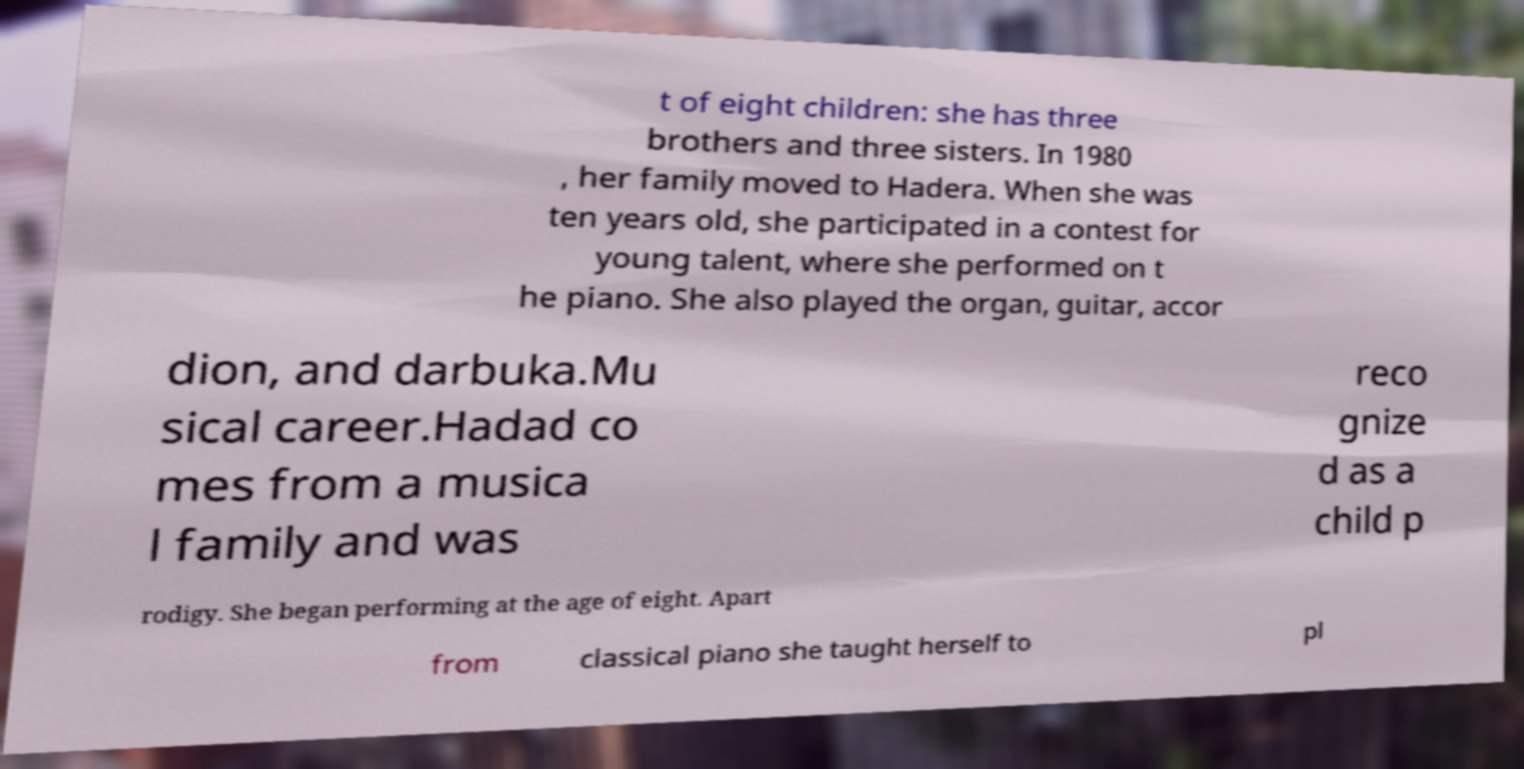There's text embedded in this image that I need extracted. Can you transcribe it verbatim? t of eight children: she has three brothers and three sisters. In 1980 , her family moved to Hadera. When she was ten years old, she participated in a contest for young talent, where she performed on t he piano. She also played the organ, guitar, accor dion, and darbuka.Mu sical career.Hadad co mes from a musica l family and was reco gnize d as a child p rodigy. She began performing at the age of eight. Apart from classical piano she taught herself to pl 